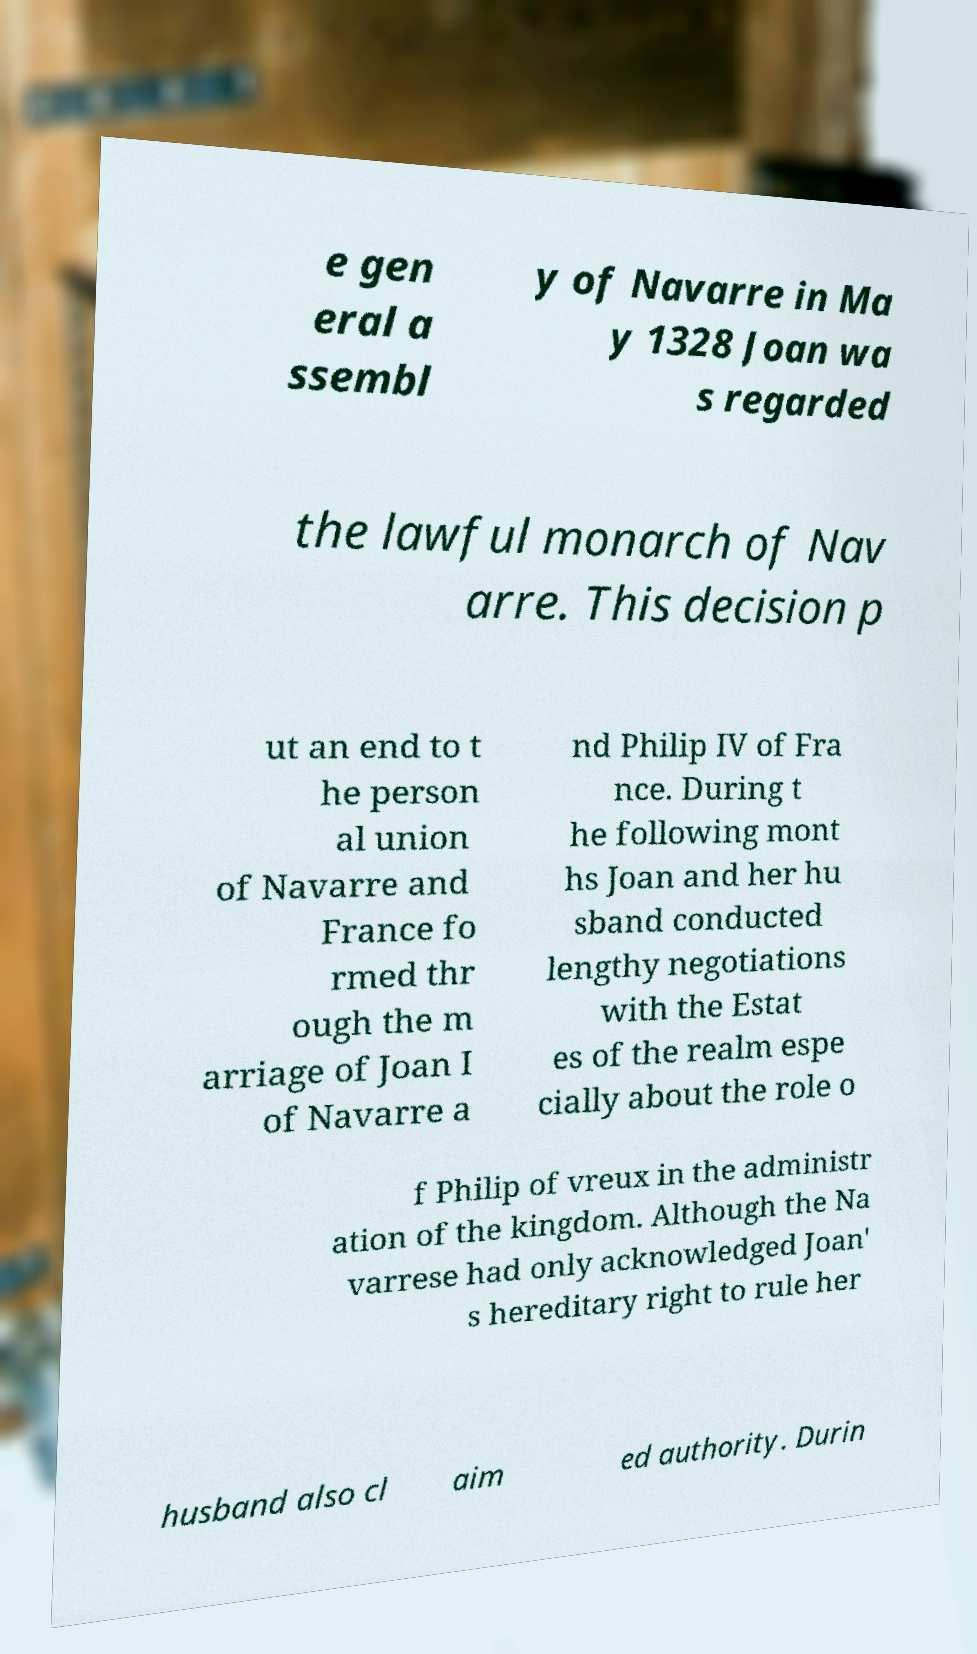Please read and relay the text visible in this image. What does it say? e gen eral a ssembl y of Navarre in Ma y 1328 Joan wa s regarded the lawful monarch of Nav arre. This decision p ut an end to t he person al union of Navarre and France fo rmed thr ough the m arriage of Joan I of Navarre a nd Philip IV of Fra nce. During t he following mont hs Joan and her hu sband conducted lengthy negotiations with the Estat es of the realm espe cially about the role o f Philip of vreux in the administr ation of the kingdom. Although the Na varrese had only acknowledged Joan' s hereditary right to rule her husband also cl aim ed authority. Durin 